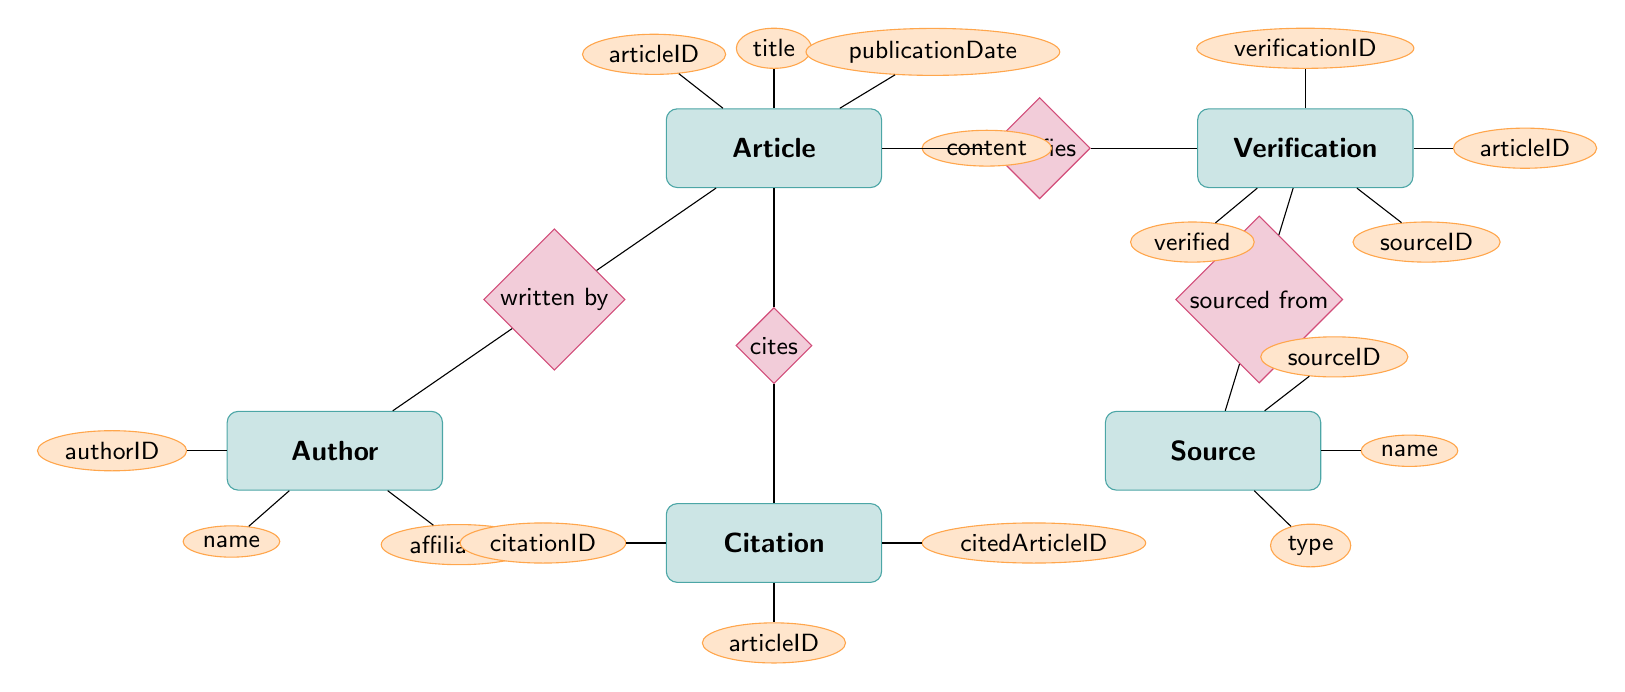What are the attributes of the Article entity? The Article entity has four attributes listed: articleID, title, publicationDate, and content. These attributes are shown directly beside the Article entity inside the diagram.
Answer: articleID, title, publicationDate, content How many attributes does the Author entity have? The Author entity has three attributes: authorID, name, and affiliation. The count of these attributes is obtained by simply counting the number of listed attributes next to the Author entity in the diagram.
Answer: three What relationship connects the Article and Author entities? The relationship that connects the Article and Author entities is labeled as "written by." This is indicated in the diagram, where the relationship is displayed as a diamond shape between the two entities.
Answer: written by Which entity is associated with the Verification entity and Source? The Verification entity is associated with the Source entity through the "sourced from" relationship. The line connecting these two entities indicates their relationship, along with its label present in the diagram.
Answer: Source What does the Verification entity check or confirm in relation to the Article? The Verification entity checks or confirms the source of the Article through the 'verified' attribute. This can be inferred from the attributes listed within the Verification entity, indicating it includes a verification flag related to the Article.
Answer: verified Which entity has a many-to-one relationship with the Citation entity? The Article entity has a many-to-one relationship with the Citation entity as signified by the "cites" relationship. This relationship implies that one Article can cite multiple citations, evident from the way connections are drawn between them.
Answer: Article What is the name of the relationship that connects the Source and Verification entities? The relationship that connects the Source and Verification entities is called "sourced from." This is clearly stated in the diagram, which visually represents the link between these two entities.
Answer: sourced from What unique identifier does the Citation entity have? The Citation entity has a unique identifier called citationID. This attribute is specifically listed within the Citation entity's attributes section in the diagram.
Answer: citationID How many relationships exist among the entities in total? There are four relationships depicted: "written by," "cites," "verifies," and "sourced from." By counting each of these labeled connections in the diagram, we can determine the total number of relationships.
Answer: four 